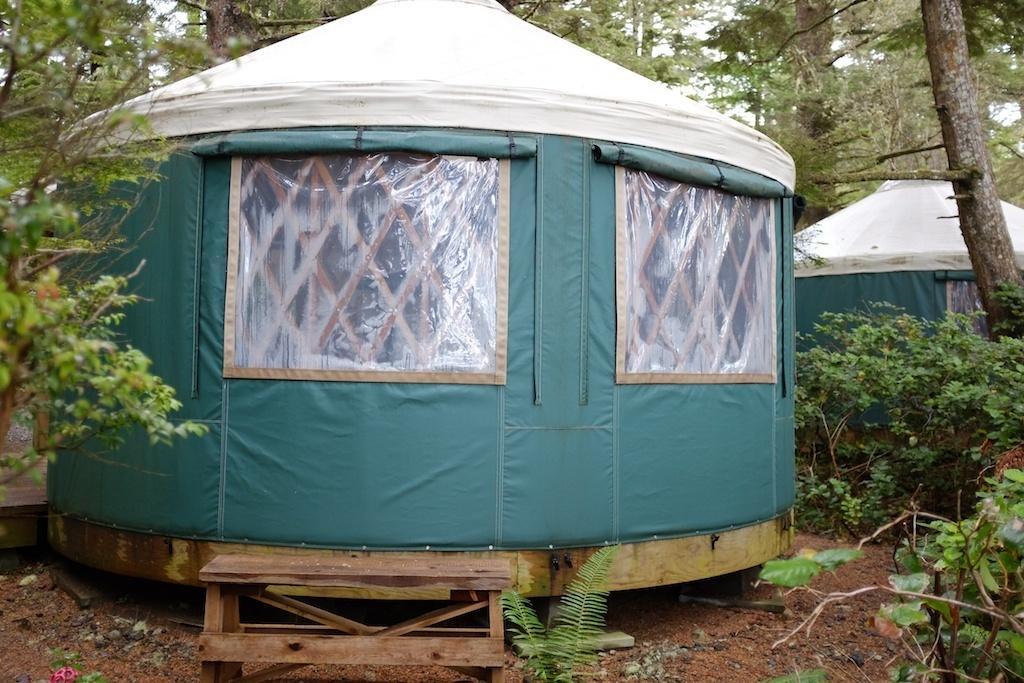Please provide a concise description of this image. In the image there is a tent house in the middle with plants and trees all around it on the land. 